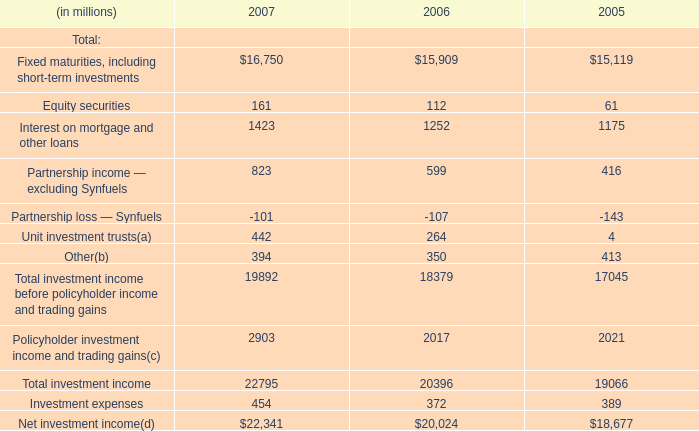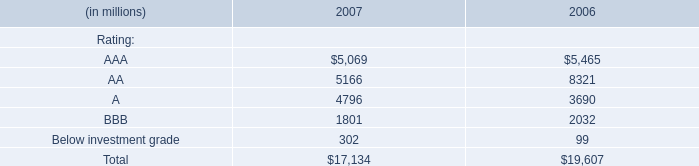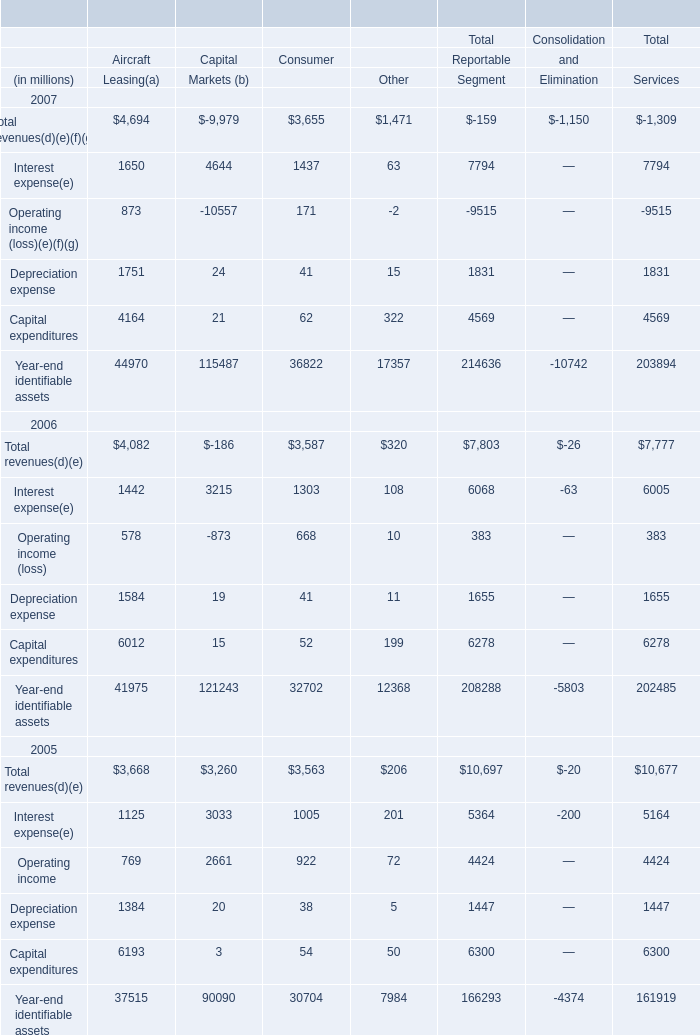What's the sum of the Operating income in the years where Interest expense is positive? (in $ in millions) 
Computations: (((873 - 10557) + 171) - 2)
Answer: -9515.0. 